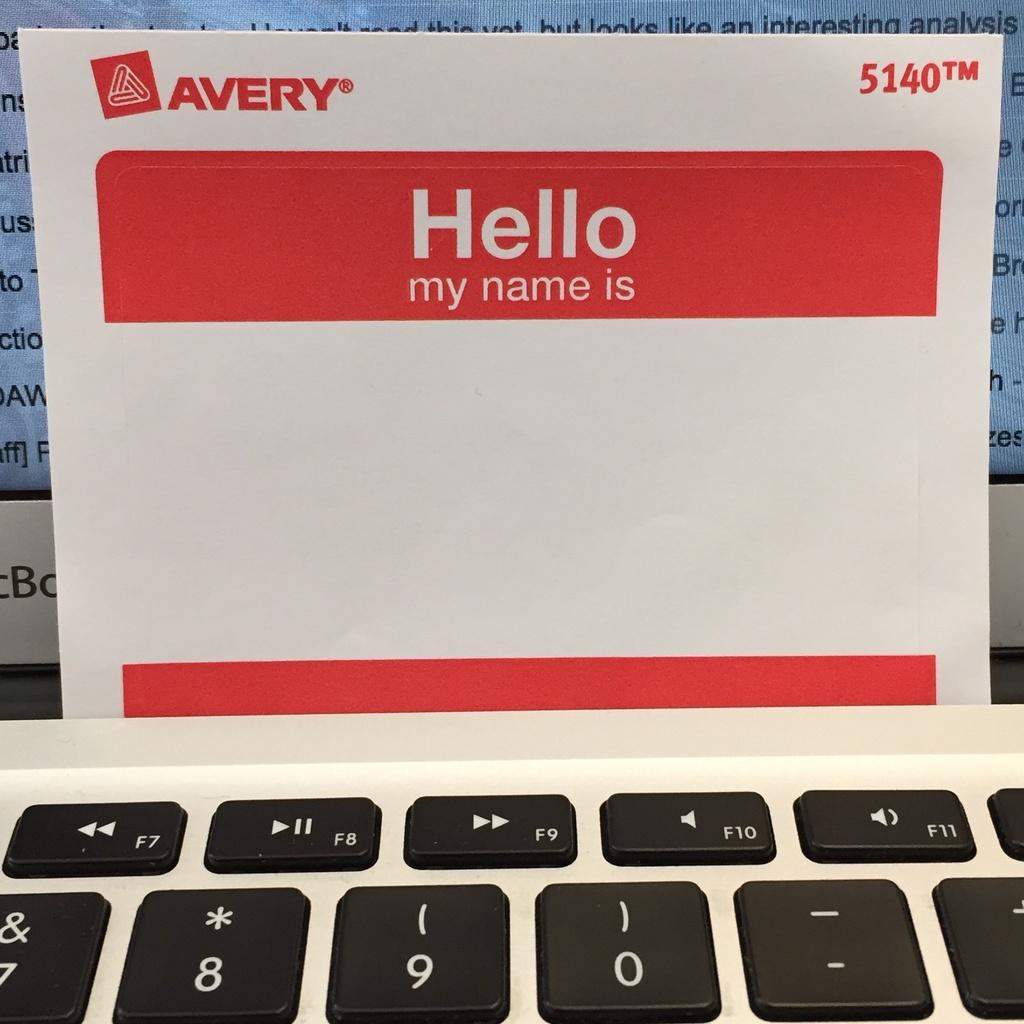<image>
Present a compact description of the photo's key features. A red and white name tag reads "Hello my name is". 